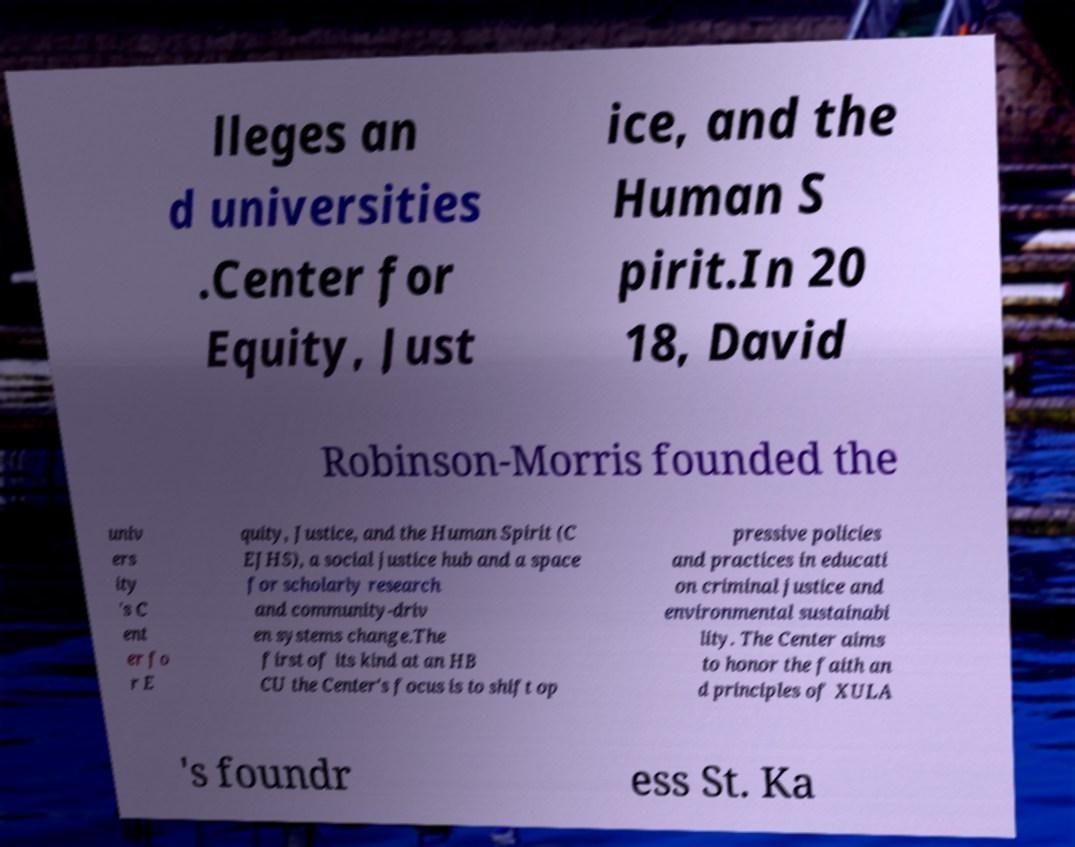Please identify and transcribe the text found in this image. lleges an d universities .Center for Equity, Just ice, and the Human S pirit.In 20 18, David Robinson-Morris founded the univ ers ity 's C ent er fo r E quity, Justice, and the Human Spirit (C EJHS), a social justice hub and a space for scholarly research and community-driv en systems change.The first of its kind at an HB CU the Center's focus is to shift op pressive policies and practices in educati on criminal justice and environmental sustainabi lity. The Center aims to honor the faith an d principles of XULA 's foundr ess St. Ka 